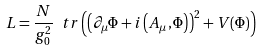Convert formula to latex. <formula><loc_0><loc_0><loc_500><loc_500>L = \frac { N } { g _ { 0 } ^ { 2 } } \ t r \left ( \left ( \partial _ { \mu } \Phi + i \left ( A _ { \mu } , \Phi \right ) \right ) ^ { 2 } + V ( \Phi ) \right )</formula> 